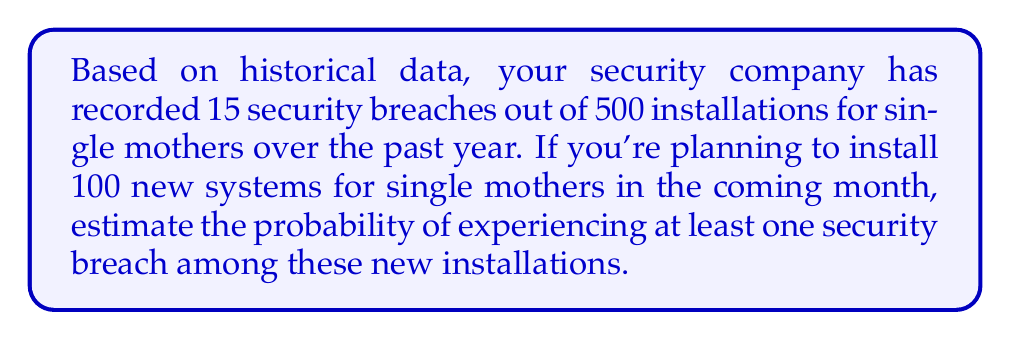Teach me how to tackle this problem. Let's approach this step-by-step:

1) First, we need to calculate the probability of a security breach for a single installation:
   $p = \frac{\text{number of breaches}}{\text{total installations}} = \frac{15}{500} = 0.03$ or 3%

2) Now, we want to find the probability of at least one breach in 100 new installations. It's easier to calculate the probability of no breaches and then subtract from 1.

3) The probability of no breach for a single installation is:
   $1 - p = 1 - 0.03 = 0.97$ or 97%

4) For all 100 installations to have no breaches, each installation must have no breach. The probability of this is:
   $0.97^{100}$

5) We can calculate this:
   $0.97^{100} \approx 0.0476$

6) Therefore, the probability of at least one breach is:
   $1 - 0.97^{100} \approx 1 - 0.0476 = 0.9524$

7) Converting to a percentage:
   $0.9524 \times 100\% = 95.24\%$

Thus, there is approximately a 95.24% chance of experiencing at least one security breach among the 100 new installations.
Answer: 95.24% 